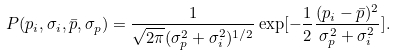<formula> <loc_0><loc_0><loc_500><loc_500>P ( p _ { i } , \sigma _ { i } , \bar { p } , \sigma _ { p } ) = \frac { 1 } { \sqrt { 2 \pi } ( \sigma _ { p } ^ { 2 } + \sigma _ { i } ^ { 2 } ) ^ { 1 / 2 } } \exp [ - \frac { 1 } { 2 } \frac { ( p _ { i } - \bar { p } ) ^ { 2 } } { \sigma _ { p } ^ { 2 } + \sigma _ { i } ^ { 2 } } ] .</formula> 